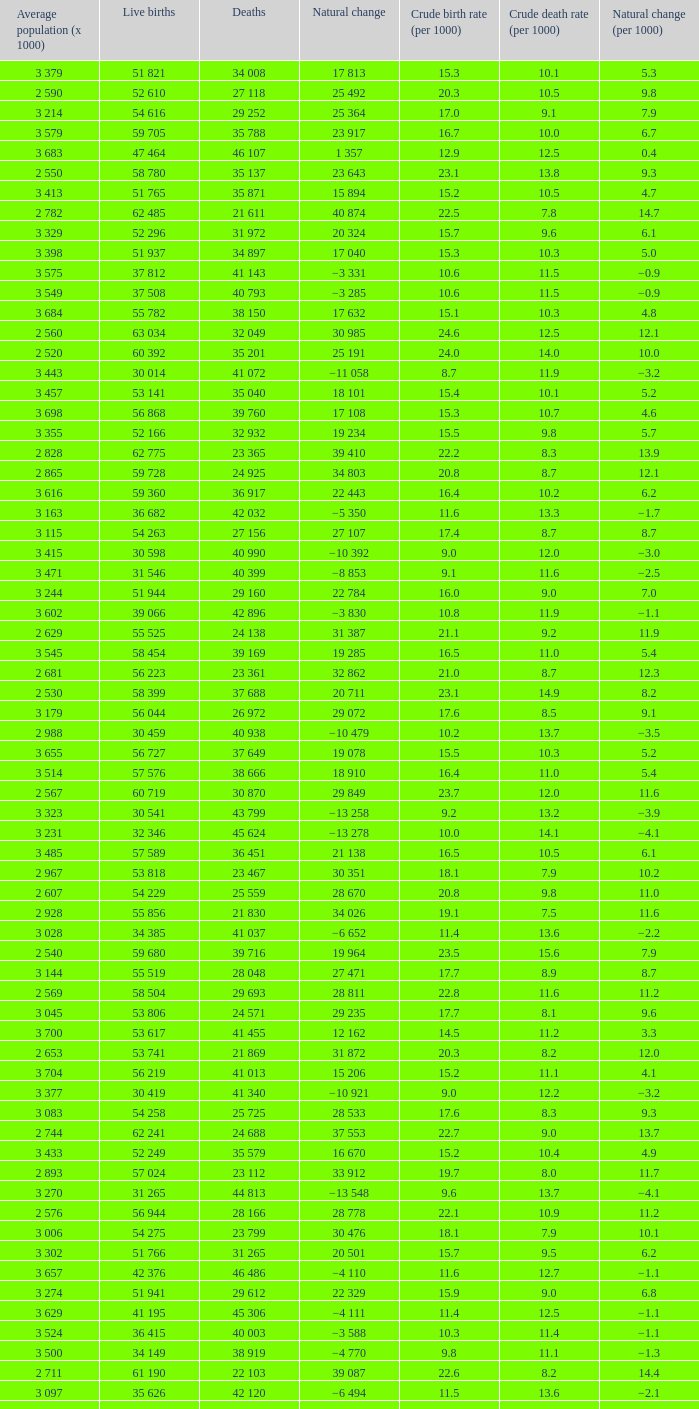Which Average population (x 1000) has a Crude death rate (per 1000) smaller than 10.9, and a Crude birth rate (per 1000) smaller than 19.7, and a Natural change (per 1000) of 8.7, and Live births of 54 263? 3 115. 